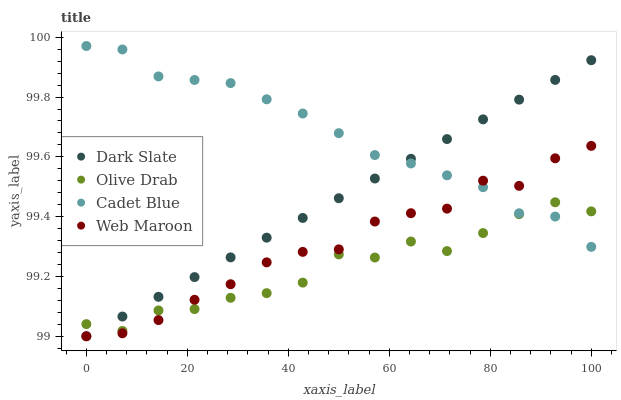Does Olive Drab have the minimum area under the curve?
Answer yes or no. Yes. Does Cadet Blue have the maximum area under the curve?
Answer yes or no. Yes. Does Web Maroon have the minimum area under the curve?
Answer yes or no. No. Does Web Maroon have the maximum area under the curve?
Answer yes or no. No. Is Dark Slate the smoothest?
Answer yes or no. Yes. Is Olive Drab the roughest?
Answer yes or no. Yes. Is Cadet Blue the smoothest?
Answer yes or no. No. Is Cadet Blue the roughest?
Answer yes or no. No. Does Dark Slate have the lowest value?
Answer yes or no. Yes. Does Cadet Blue have the lowest value?
Answer yes or no. No. Does Cadet Blue have the highest value?
Answer yes or no. Yes. Does Web Maroon have the highest value?
Answer yes or no. No. Does Olive Drab intersect Web Maroon?
Answer yes or no. Yes. Is Olive Drab less than Web Maroon?
Answer yes or no. No. Is Olive Drab greater than Web Maroon?
Answer yes or no. No. 